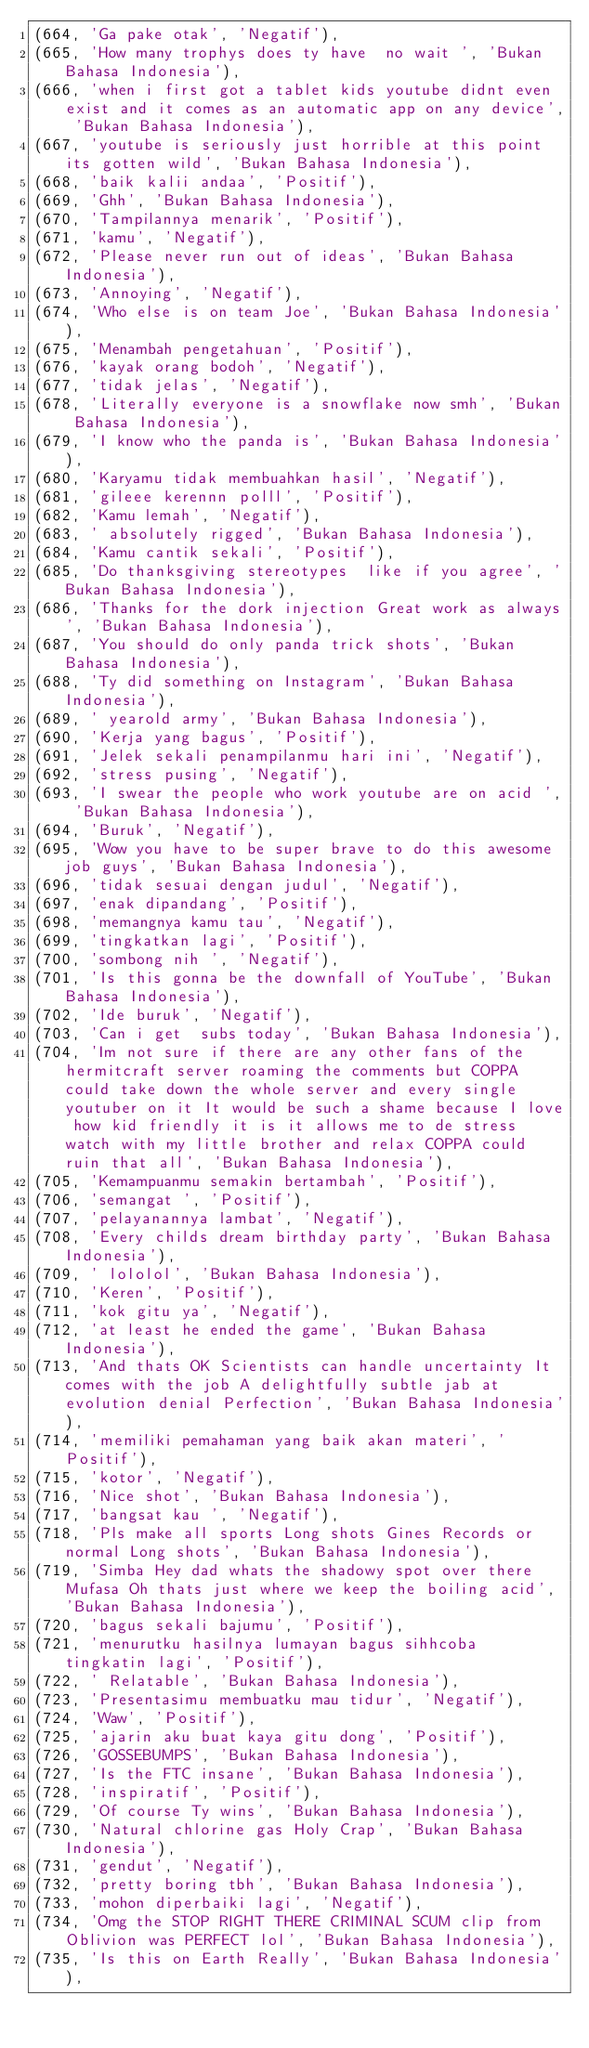Convert code to text. <code><loc_0><loc_0><loc_500><loc_500><_SQL_>(664, 'Ga pake otak', 'Negatif'),
(665, 'How many trophys does ty have  no wait ', 'Bukan Bahasa Indonesia'),
(666, 'when i first got a tablet kids youtube didnt even exist and it comes as an automatic app on any device', 'Bukan Bahasa Indonesia'),
(667, 'youtube is seriously just horrible at this point its gotten wild', 'Bukan Bahasa Indonesia'),
(668, 'baik kalii andaa', 'Positif'),
(669, 'Ghh', 'Bukan Bahasa Indonesia'),
(670, 'Tampilannya menarik', 'Positif'),
(671, 'kamu', 'Negatif'),
(672, 'Please never run out of ideas', 'Bukan Bahasa Indonesia'),
(673, 'Annoying', 'Negatif'),
(674, 'Who else is on team Joe', 'Bukan Bahasa Indonesia'),
(675, 'Menambah pengetahuan', 'Positif'),
(676, 'kayak orang bodoh', 'Negatif'),
(677, 'tidak jelas', 'Negatif'),
(678, 'Literally everyone is a snowflake now smh', 'Bukan Bahasa Indonesia'),
(679, 'I know who the panda is', 'Bukan Bahasa Indonesia'),
(680, 'Karyamu tidak membuahkan hasil', 'Negatif'),
(681, 'gileee kerennn polll', 'Positif'),
(682, 'Kamu lemah', 'Negatif'),
(683, ' absolutely rigged', 'Bukan Bahasa Indonesia'),
(684, 'Kamu cantik sekali', 'Positif'),
(685, 'Do thanksgiving stereotypes  like if you agree', 'Bukan Bahasa Indonesia'),
(686, 'Thanks for the dork injection Great work as always', 'Bukan Bahasa Indonesia'),
(687, 'You should do only panda trick shots', 'Bukan Bahasa Indonesia'),
(688, 'Ty did something on Instagram', 'Bukan Bahasa Indonesia'),
(689, ' yearold army', 'Bukan Bahasa Indonesia'),
(690, 'Kerja yang bagus', 'Positif'),
(691, 'Jelek sekali penampilanmu hari ini', 'Negatif'),
(692, 'stress pusing', 'Negatif'),
(693, 'I swear the people who work youtube are on acid ', 'Bukan Bahasa Indonesia'),
(694, 'Buruk', 'Negatif'),
(695, 'Wow you have to be super brave to do this awesome job guys', 'Bukan Bahasa Indonesia'),
(696, 'tidak sesuai dengan judul', 'Negatif'),
(697, 'enak dipandang', 'Positif'),
(698, 'memangnya kamu tau', 'Negatif'),
(699, 'tingkatkan lagi', 'Positif'),
(700, 'sombong nih ', 'Negatif'),
(701, 'Is this gonna be the downfall of YouTube', 'Bukan Bahasa Indonesia'),
(702, 'Ide buruk', 'Negatif'),
(703, 'Can i get  subs today', 'Bukan Bahasa Indonesia'),
(704, 'Im not sure if there are any other fans of the hermitcraft server roaming the comments but COPPA could take down the whole server and every single youtuber on it It would be such a shame because I love how kid friendly it is it allows me to de stress watch with my little brother and relax COPPA could ruin that all', 'Bukan Bahasa Indonesia'),
(705, 'Kemampuanmu semakin bertambah', 'Positif'),
(706, 'semangat ', 'Positif'),
(707, 'pelayanannya lambat', 'Negatif'),
(708, 'Every childs dream birthday party', 'Bukan Bahasa Indonesia'),
(709, ' lololol', 'Bukan Bahasa Indonesia'),
(710, 'Keren', 'Positif'),
(711, 'kok gitu ya', 'Negatif'),
(712, 'at least he ended the game', 'Bukan Bahasa Indonesia'),
(713, 'And thats OK Scientists can handle uncertainty It comes with the job A delightfully subtle jab at evolution denial Perfection', 'Bukan Bahasa Indonesia'),
(714, 'memiliki pemahaman yang baik akan materi', 'Positif'),
(715, 'kotor', 'Negatif'),
(716, 'Nice shot', 'Bukan Bahasa Indonesia'),
(717, 'bangsat kau ', 'Negatif'),
(718, 'Pls make all sports Long shots Gines Records or normal Long shots', 'Bukan Bahasa Indonesia'),
(719, 'Simba Hey dad whats the shadowy spot over there Mufasa Oh thats just where we keep the boiling acid', 'Bukan Bahasa Indonesia'),
(720, 'bagus sekali bajumu', 'Positif'),
(721, 'menurutku hasilnya lumayan bagus sihhcoba tingkatin lagi', 'Positif'),
(722, ' Relatable', 'Bukan Bahasa Indonesia'),
(723, 'Presentasimu membuatku mau tidur', 'Negatif'),
(724, 'Waw', 'Positif'),
(725, 'ajarin aku buat kaya gitu dong', 'Positif'),
(726, 'GOSSEBUMPS', 'Bukan Bahasa Indonesia'),
(727, 'Is the FTC insane', 'Bukan Bahasa Indonesia'),
(728, 'inspiratif', 'Positif'),
(729, 'Of course Ty wins', 'Bukan Bahasa Indonesia'),
(730, 'Natural chlorine gas Holy Crap', 'Bukan Bahasa Indonesia'),
(731, 'gendut', 'Negatif'),
(732, 'pretty boring tbh', 'Bukan Bahasa Indonesia'),
(733, 'mohon diperbaiki lagi', 'Negatif'),
(734, 'Omg the STOP RIGHT THERE CRIMINAL SCUM clip from Oblivion was PERFECT lol', 'Bukan Bahasa Indonesia'),
(735, 'Is this on Earth Really', 'Bukan Bahasa Indonesia'),</code> 